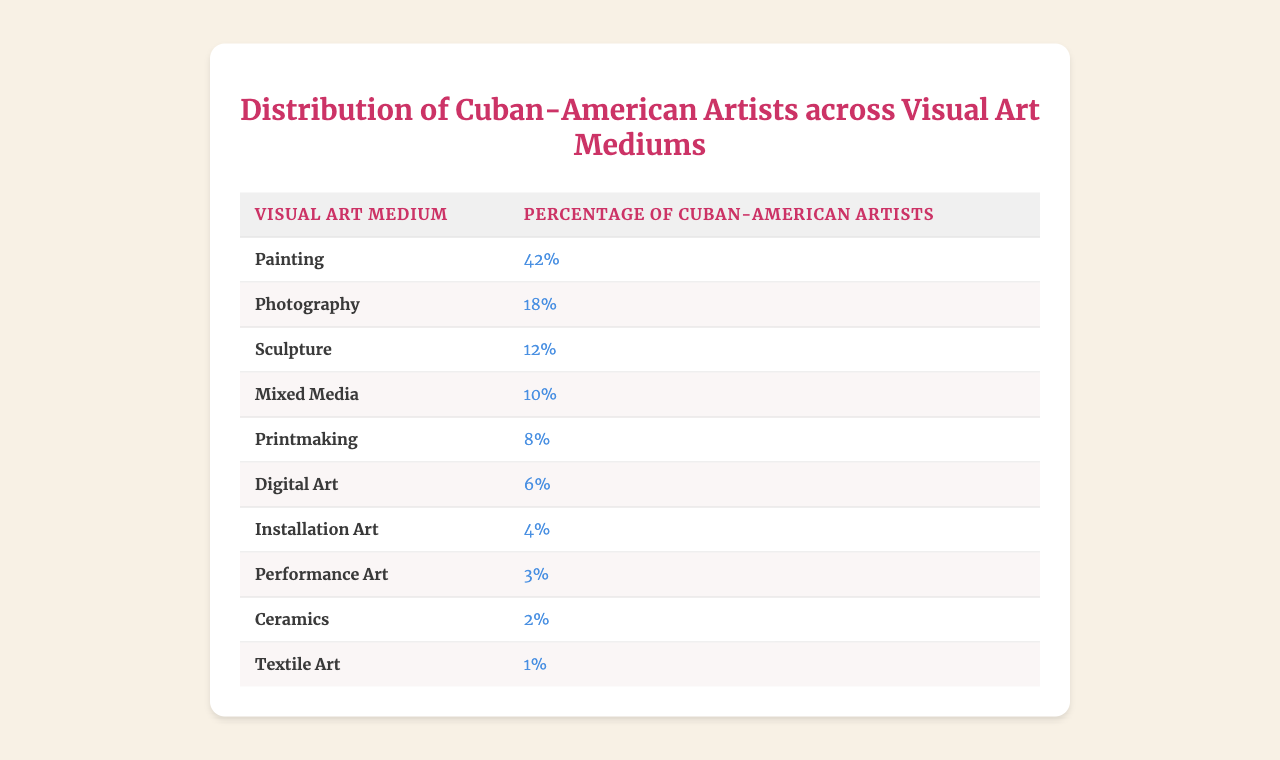What is the percentage of Cuban-American artists working in painting? The table shows that the percentage of Cuban-American artists working in painting is specifically listed, which is 42%.
Answer: 42% Which visual art medium has the least representation among Cuban-American artists? Looking at the percentages for each medium, textile art is noted to have the least representation at 1%.
Answer: Textile Art What is the combined percentage of Cuban-American artists involved in photography and sculpture? We can add the percentages of photography (18%) and sculpture (12%) together to find the combined total: 18% + 12% = 30%.
Answer: 30% Is the percentage of Cuban-American artists participating in performance art greater than that in ceramics? The table shows performance art at 3% and ceramics at 2%, therefore performance art has a higher percentage than ceramics.
Answer: Yes What is the difference in percentage between the artists in mixed media and digital art? We subtract the percentage of digital art (6%) from mixed media (10%): 10% - 6% = 4%.
Answer: 4% If you combine the percentages of installation art and performance art, what is the total? The percentages for installation art (4%) and performance art (3%) can be added together: 4% + 3% = 7%.
Answer: 7% What percentage of Cuban-American artists are engaged in both ceramics and textile art combined? We add the percentages of ceramics (2%) and textile art (1%) together: 2% + 1% = 3%.
Answer: 3% Which two visual art mediums have the highest combined percentage of Cuban-American artists? The mediums with the highest individual percentages are painting (42%) and photography (18%). Their combined percentage is: 42% + 18% = 60%.
Answer: 60% What percentage of artists work in digital art compared to those who work in printmaking? Digital art represents 6%, while printmaking represents 8%. Printmaking has a higher percentage than digital art.
Answer: Printmaking is higher Is the percentage of artists working in mixed media more than twice that of those working in textiles? Mixed media has 10% and textile art has 1%. Twice the percentage of textile art is 2%. Compared to mixed media (10%), it is indeed more than double.
Answer: Yes 